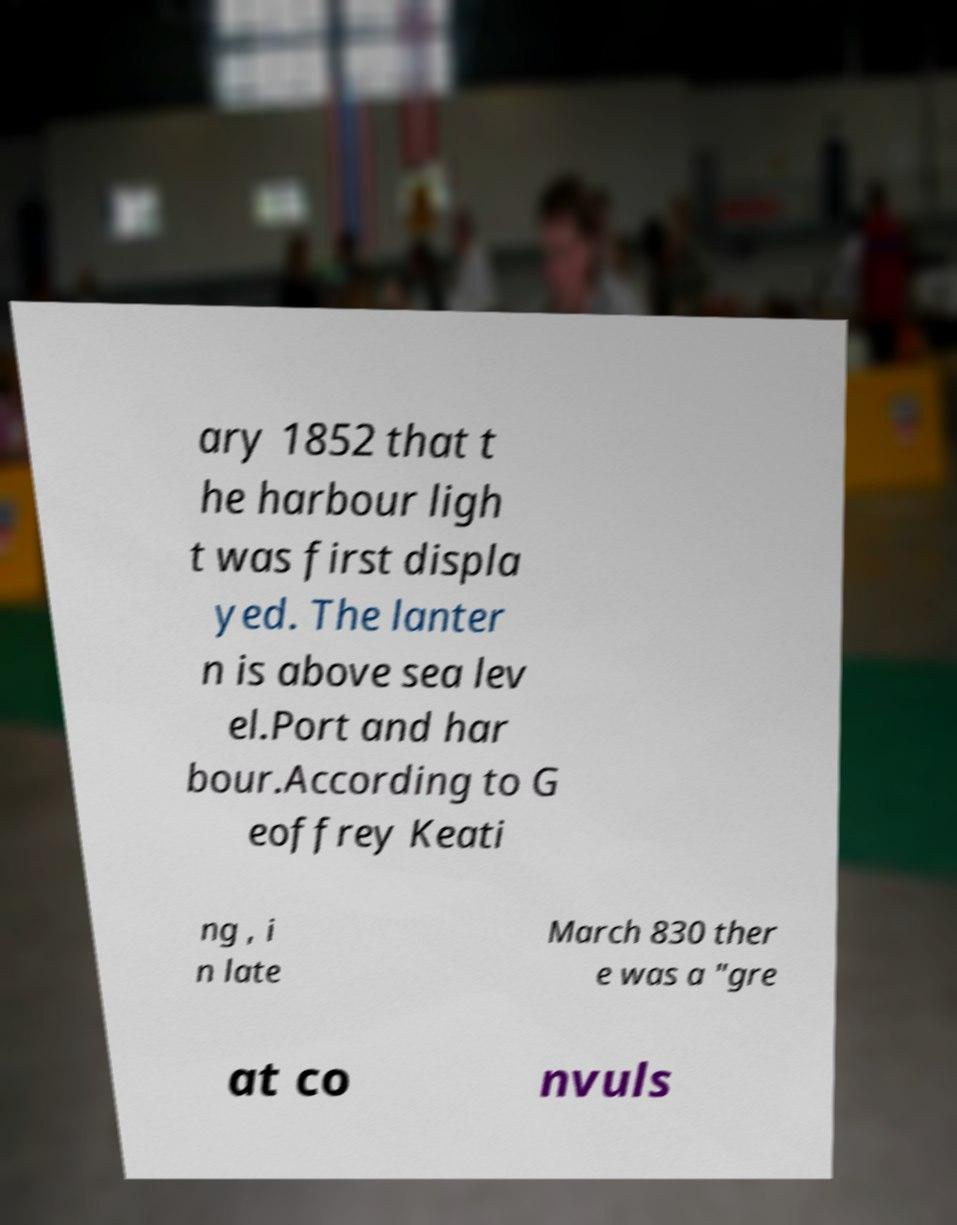Could you extract and type out the text from this image? ary 1852 that t he harbour ligh t was first displa yed. The lanter n is above sea lev el.Port and har bour.According to G eoffrey Keati ng , i n late March 830 ther e was a "gre at co nvuls 